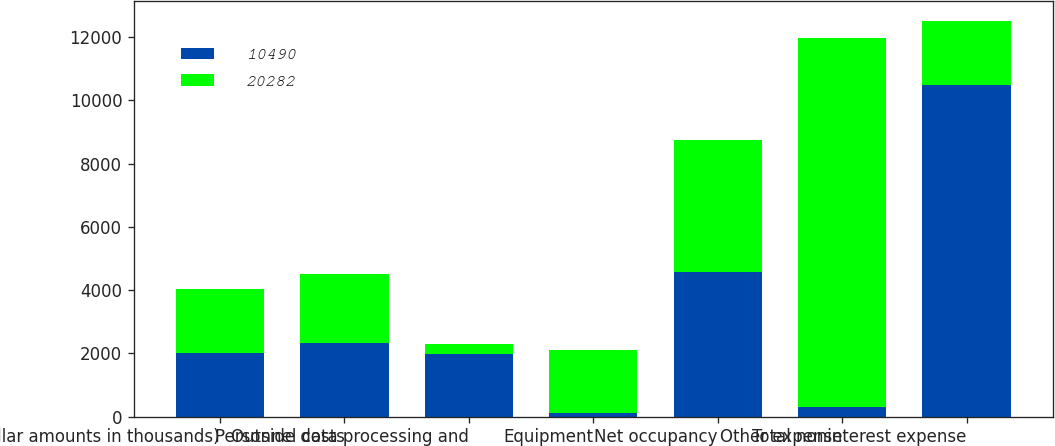<chart> <loc_0><loc_0><loc_500><loc_500><stacked_bar_chart><ecel><fcel>(dollar amounts in thousands)<fcel>Personnel costs<fcel>Outside data processing and<fcel>Equipment<fcel>Net occupancy<fcel>Other expense<fcel>Total noninterest expense<nl><fcel>10490<fcel>2015<fcel>2332<fcel>1990<fcel>110<fcel>4587<fcel>318<fcel>10490<nl><fcel>20282<fcel>2014<fcel>2165<fcel>306<fcel>2003<fcel>4150<fcel>11644<fcel>2015<nl></chart> 